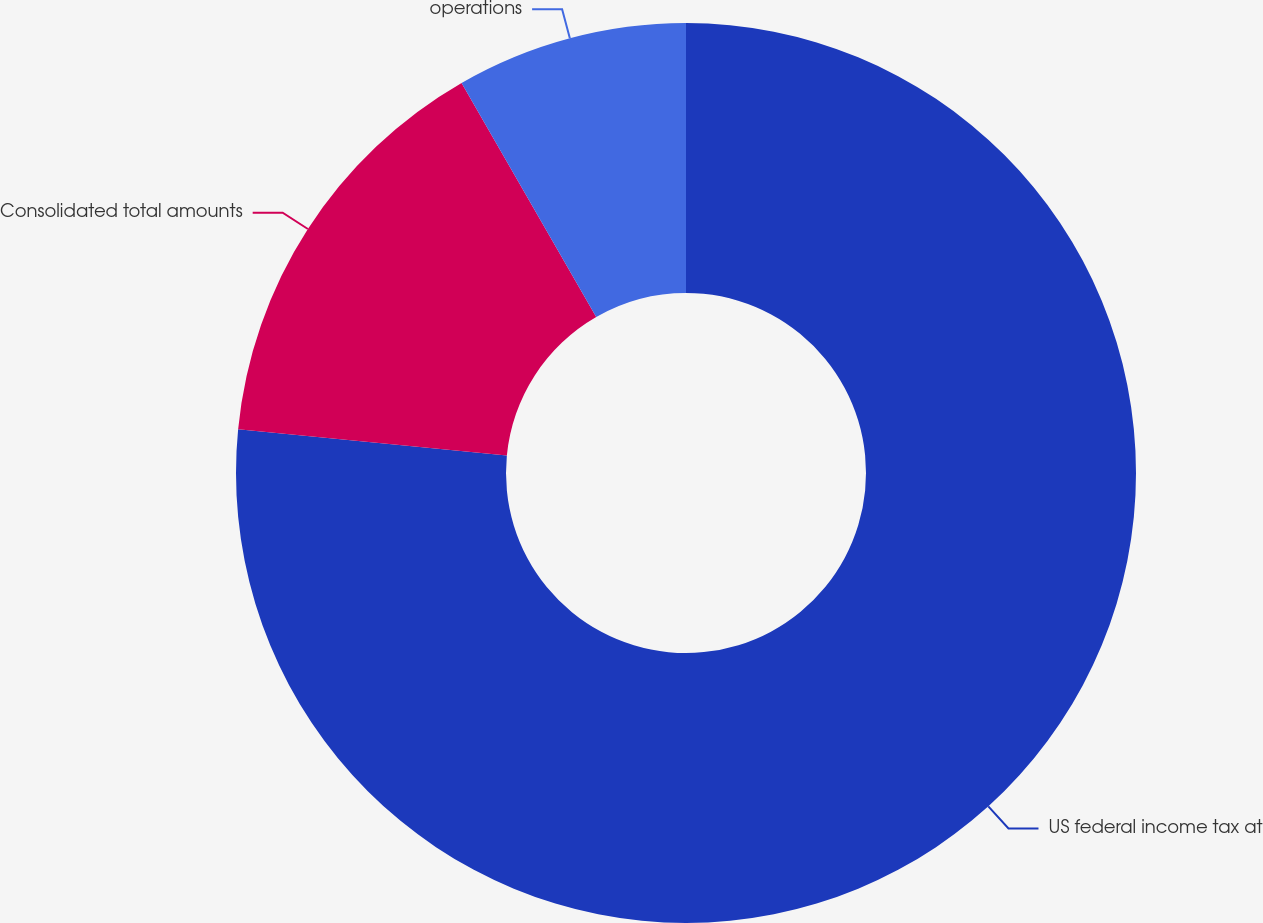<chart> <loc_0><loc_0><loc_500><loc_500><pie_chart><fcel>US federal income tax at<fcel>Consolidated total amounts<fcel>operations<nl><fcel>76.55%<fcel>15.14%<fcel>8.31%<nl></chart> 